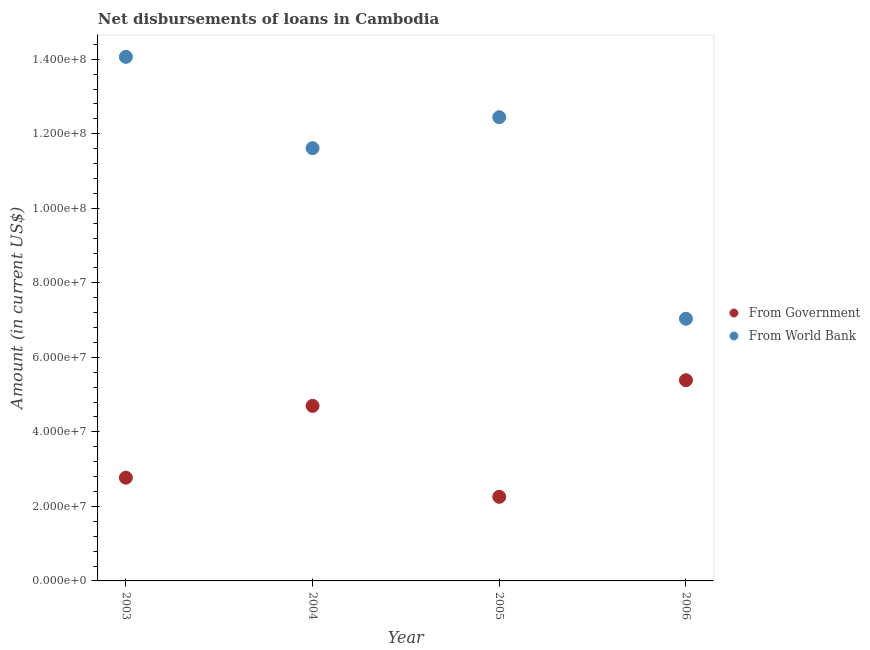How many different coloured dotlines are there?
Your response must be concise. 2. What is the net disbursements of loan from government in 2006?
Your response must be concise. 5.39e+07. Across all years, what is the maximum net disbursements of loan from government?
Provide a succinct answer. 5.39e+07. Across all years, what is the minimum net disbursements of loan from world bank?
Keep it short and to the point. 7.04e+07. In which year was the net disbursements of loan from world bank maximum?
Offer a terse response. 2003. What is the total net disbursements of loan from government in the graph?
Make the answer very short. 1.51e+08. What is the difference between the net disbursements of loan from world bank in 2003 and that in 2005?
Ensure brevity in your answer.  1.62e+07. What is the difference between the net disbursements of loan from world bank in 2003 and the net disbursements of loan from government in 2004?
Provide a short and direct response. 9.37e+07. What is the average net disbursements of loan from world bank per year?
Your response must be concise. 1.13e+08. In the year 2004, what is the difference between the net disbursements of loan from government and net disbursements of loan from world bank?
Your answer should be compact. -6.92e+07. What is the ratio of the net disbursements of loan from government in 2004 to that in 2005?
Your answer should be compact. 2.08. Is the difference between the net disbursements of loan from government in 2005 and 2006 greater than the difference between the net disbursements of loan from world bank in 2005 and 2006?
Your answer should be very brief. No. What is the difference between the highest and the second highest net disbursements of loan from world bank?
Give a very brief answer. 1.62e+07. What is the difference between the highest and the lowest net disbursements of loan from government?
Your answer should be very brief. 3.13e+07. In how many years, is the net disbursements of loan from world bank greater than the average net disbursements of loan from world bank taken over all years?
Your answer should be very brief. 3. Is the sum of the net disbursements of loan from government in 2004 and 2006 greater than the maximum net disbursements of loan from world bank across all years?
Your answer should be compact. No. Is the net disbursements of loan from world bank strictly greater than the net disbursements of loan from government over the years?
Your response must be concise. Yes. Is the net disbursements of loan from government strictly less than the net disbursements of loan from world bank over the years?
Your response must be concise. Yes. What is the difference between two consecutive major ticks on the Y-axis?
Your answer should be very brief. 2.00e+07. Are the values on the major ticks of Y-axis written in scientific E-notation?
Your response must be concise. Yes. Does the graph contain any zero values?
Provide a succinct answer. No. Where does the legend appear in the graph?
Keep it short and to the point. Center right. What is the title of the graph?
Ensure brevity in your answer.  Net disbursements of loans in Cambodia. What is the label or title of the X-axis?
Offer a very short reply. Year. What is the label or title of the Y-axis?
Make the answer very short. Amount (in current US$). What is the Amount (in current US$) in From Government in 2003?
Ensure brevity in your answer.  2.77e+07. What is the Amount (in current US$) in From World Bank in 2003?
Offer a terse response. 1.41e+08. What is the Amount (in current US$) in From Government in 2004?
Your response must be concise. 4.70e+07. What is the Amount (in current US$) in From World Bank in 2004?
Make the answer very short. 1.16e+08. What is the Amount (in current US$) of From Government in 2005?
Your response must be concise. 2.26e+07. What is the Amount (in current US$) in From World Bank in 2005?
Your answer should be compact. 1.24e+08. What is the Amount (in current US$) in From Government in 2006?
Offer a very short reply. 5.39e+07. What is the Amount (in current US$) in From World Bank in 2006?
Provide a short and direct response. 7.04e+07. Across all years, what is the maximum Amount (in current US$) in From Government?
Your answer should be very brief. 5.39e+07. Across all years, what is the maximum Amount (in current US$) in From World Bank?
Your answer should be very brief. 1.41e+08. Across all years, what is the minimum Amount (in current US$) of From Government?
Provide a short and direct response. 2.26e+07. Across all years, what is the minimum Amount (in current US$) in From World Bank?
Make the answer very short. 7.04e+07. What is the total Amount (in current US$) of From Government in the graph?
Offer a very short reply. 1.51e+08. What is the total Amount (in current US$) of From World Bank in the graph?
Your answer should be very brief. 4.52e+08. What is the difference between the Amount (in current US$) of From Government in 2003 and that in 2004?
Keep it short and to the point. -1.93e+07. What is the difference between the Amount (in current US$) of From World Bank in 2003 and that in 2004?
Provide a short and direct response. 2.45e+07. What is the difference between the Amount (in current US$) of From Government in 2003 and that in 2005?
Your answer should be compact. 5.13e+06. What is the difference between the Amount (in current US$) in From World Bank in 2003 and that in 2005?
Ensure brevity in your answer.  1.62e+07. What is the difference between the Amount (in current US$) of From Government in 2003 and that in 2006?
Offer a very short reply. -2.62e+07. What is the difference between the Amount (in current US$) in From World Bank in 2003 and that in 2006?
Ensure brevity in your answer.  7.03e+07. What is the difference between the Amount (in current US$) of From Government in 2004 and that in 2005?
Offer a very short reply. 2.44e+07. What is the difference between the Amount (in current US$) in From World Bank in 2004 and that in 2005?
Provide a short and direct response. -8.31e+06. What is the difference between the Amount (in current US$) of From Government in 2004 and that in 2006?
Make the answer very short. -6.88e+06. What is the difference between the Amount (in current US$) of From World Bank in 2004 and that in 2006?
Your response must be concise. 4.58e+07. What is the difference between the Amount (in current US$) in From Government in 2005 and that in 2006?
Make the answer very short. -3.13e+07. What is the difference between the Amount (in current US$) in From World Bank in 2005 and that in 2006?
Provide a succinct answer. 5.41e+07. What is the difference between the Amount (in current US$) in From Government in 2003 and the Amount (in current US$) in From World Bank in 2004?
Provide a succinct answer. -8.84e+07. What is the difference between the Amount (in current US$) in From Government in 2003 and the Amount (in current US$) in From World Bank in 2005?
Your response must be concise. -9.67e+07. What is the difference between the Amount (in current US$) of From Government in 2003 and the Amount (in current US$) of From World Bank in 2006?
Keep it short and to the point. -4.27e+07. What is the difference between the Amount (in current US$) of From Government in 2004 and the Amount (in current US$) of From World Bank in 2005?
Your answer should be compact. -7.75e+07. What is the difference between the Amount (in current US$) of From Government in 2004 and the Amount (in current US$) of From World Bank in 2006?
Provide a succinct answer. -2.34e+07. What is the difference between the Amount (in current US$) in From Government in 2005 and the Amount (in current US$) in From World Bank in 2006?
Your answer should be very brief. -4.78e+07. What is the average Amount (in current US$) in From Government per year?
Give a very brief answer. 3.78e+07. What is the average Amount (in current US$) in From World Bank per year?
Offer a terse response. 1.13e+08. In the year 2003, what is the difference between the Amount (in current US$) in From Government and Amount (in current US$) in From World Bank?
Provide a short and direct response. -1.13e+08. In the year 2004, what is the difference between the Amount (in current US$) in From Government and Amount (in current US$) in From World Bank?
Your response must be concise. -6.92e+07. In the year 2005, what is the difference between the Amount (in current US$) of From Government and Amount (in current US$) of From World Bank?
Keep it short and to the point. -1.02e+08. In the year 2006, what is the difference between the Amount (in current US$) of From Government and Amount (in current US$) of From World Bank?
Ensure brevity in your answer.  -1.65e+07. What is the ratio of the Amount (in current US$) in From Government in 2003 to that in 2004?
Give a very brief answer. 0.59. What is the ratio of the Amount (in current US$) of From World Bank in 2003 to that in 2004?
Offer a very short reply. 1.21. What is the ratio of the Amount (in current US$) in From Government in 2003 to that in 2005?
Keep it short and to the point. 1.23. What is the ratio of the Amount (in current US$) of From World Bank in 2003 to that in 2005?
Provide a succinct answer. 1.13. What is the ratio of the Amount (in current US$) of From Government in 2003 to that in 2006?
Make the answer very short. 0.51. What is the ratio of the Amount (in current US$) in From World Bank in 2003 to that in 2006?
Keep it short and to the point. 2. What is the ratio of the Amount (in current US$) in From Government in 2004 to that in 2005?
Make the answer very short. 2.08. What is the ratio of the Amount (in current US$) in From World Bank in 2004 to that in 2005?
Offer a terse response. 0.93. What is the ratio of the Amount (in current US$) of From Government in 2004 to that in 2006?
Make the answer very short. 0.87. What is the ratio of the Amount (in current US$) in From World Bank in 2004 to that in 2006?
Provide a short and direct response. 1.65. What is the ratio of the Amount (in current US$) of From Government in 2005 to that in 2006?
Your answer should be very brief. 0.42. What is the ratio of the Amount (in current US$) in From World Bank in 2005 to that in 2006?
Ensure brevity in your answer.  1.77. What is the difference between the highest and the second highest Amount (in current US$) in From Government?
Make the answer very short. 6.88e+06. What is the difference between the highest and the second highest Amount (in current US$) in From World Bank?
Your response must be concise. 1.62e+07. What is the difference between the highest and the lowest Amount (in current US$) of From Government?
Your answer should be compact. 3.13e+07. What is the difference between the highest and the lowest Amount (in current US$) in From World Bank?
Your answer should be compact. 7.03e+07. 